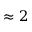Convert formula to latex. <formula><loc_0><loc_0><loc_500><loc_500>\approx 2</formula> 